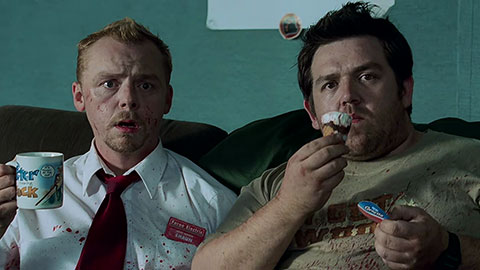Can you narrate a short story based on this image, where the characters are in a fantasy world? In the mystical realm of Fantasia, where dragons soared and magic flowed, there were two unlikely heroes: Shaun, a brave knight with a blood-stained armor, and Ed, a jovial bard known for his enchanted mug and magical snacks. One fateful day, they found themselves in the enchanted inn, the Dragon's Rest. Shaun had just returned from a fierce battle with the orc horde, victorious but weary. Ed, meanwhile, sat beside him, munching on a magical ice cream that never melted and kept spirits high. As they reclined on the emerald green couch, a sudden commotion outside the inn turned their attention to the window. The goblin king had arrived with his legion to reclaim Fantasia. With a sigh and a shared glance, they knew it was time to defend their homeland once more. With Shaun's sword ready and Ed's enchanting melodies filling the air, they stepped out into the dusk, ready to weave their legend in the annals of Fantasia. 